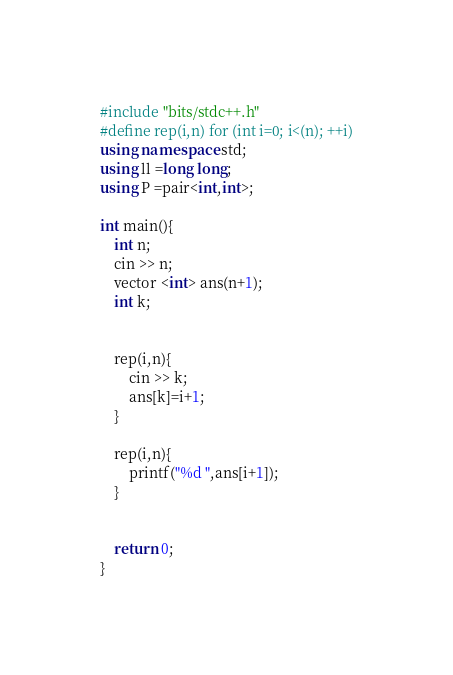<code> <loc_0><loc_0><loc_500><loc_500><_C++_>#include "bits/stdc++.h"
#define rep(i,n) for (int i=0; i<(n); ++i)
using namespace std;
using ll =long long;
using P =pair<int,int>;

int main(){
    int n;
    cin >> n;
    vector <int> ans(n+1);
    int k;
    

    rep(i,n){
        cin >> k;
        ans[k]=i+1;
    }

    rep(i,n){
        printf("%d ",ans[i+1]);
    }
    

    return 0;
}</code> 